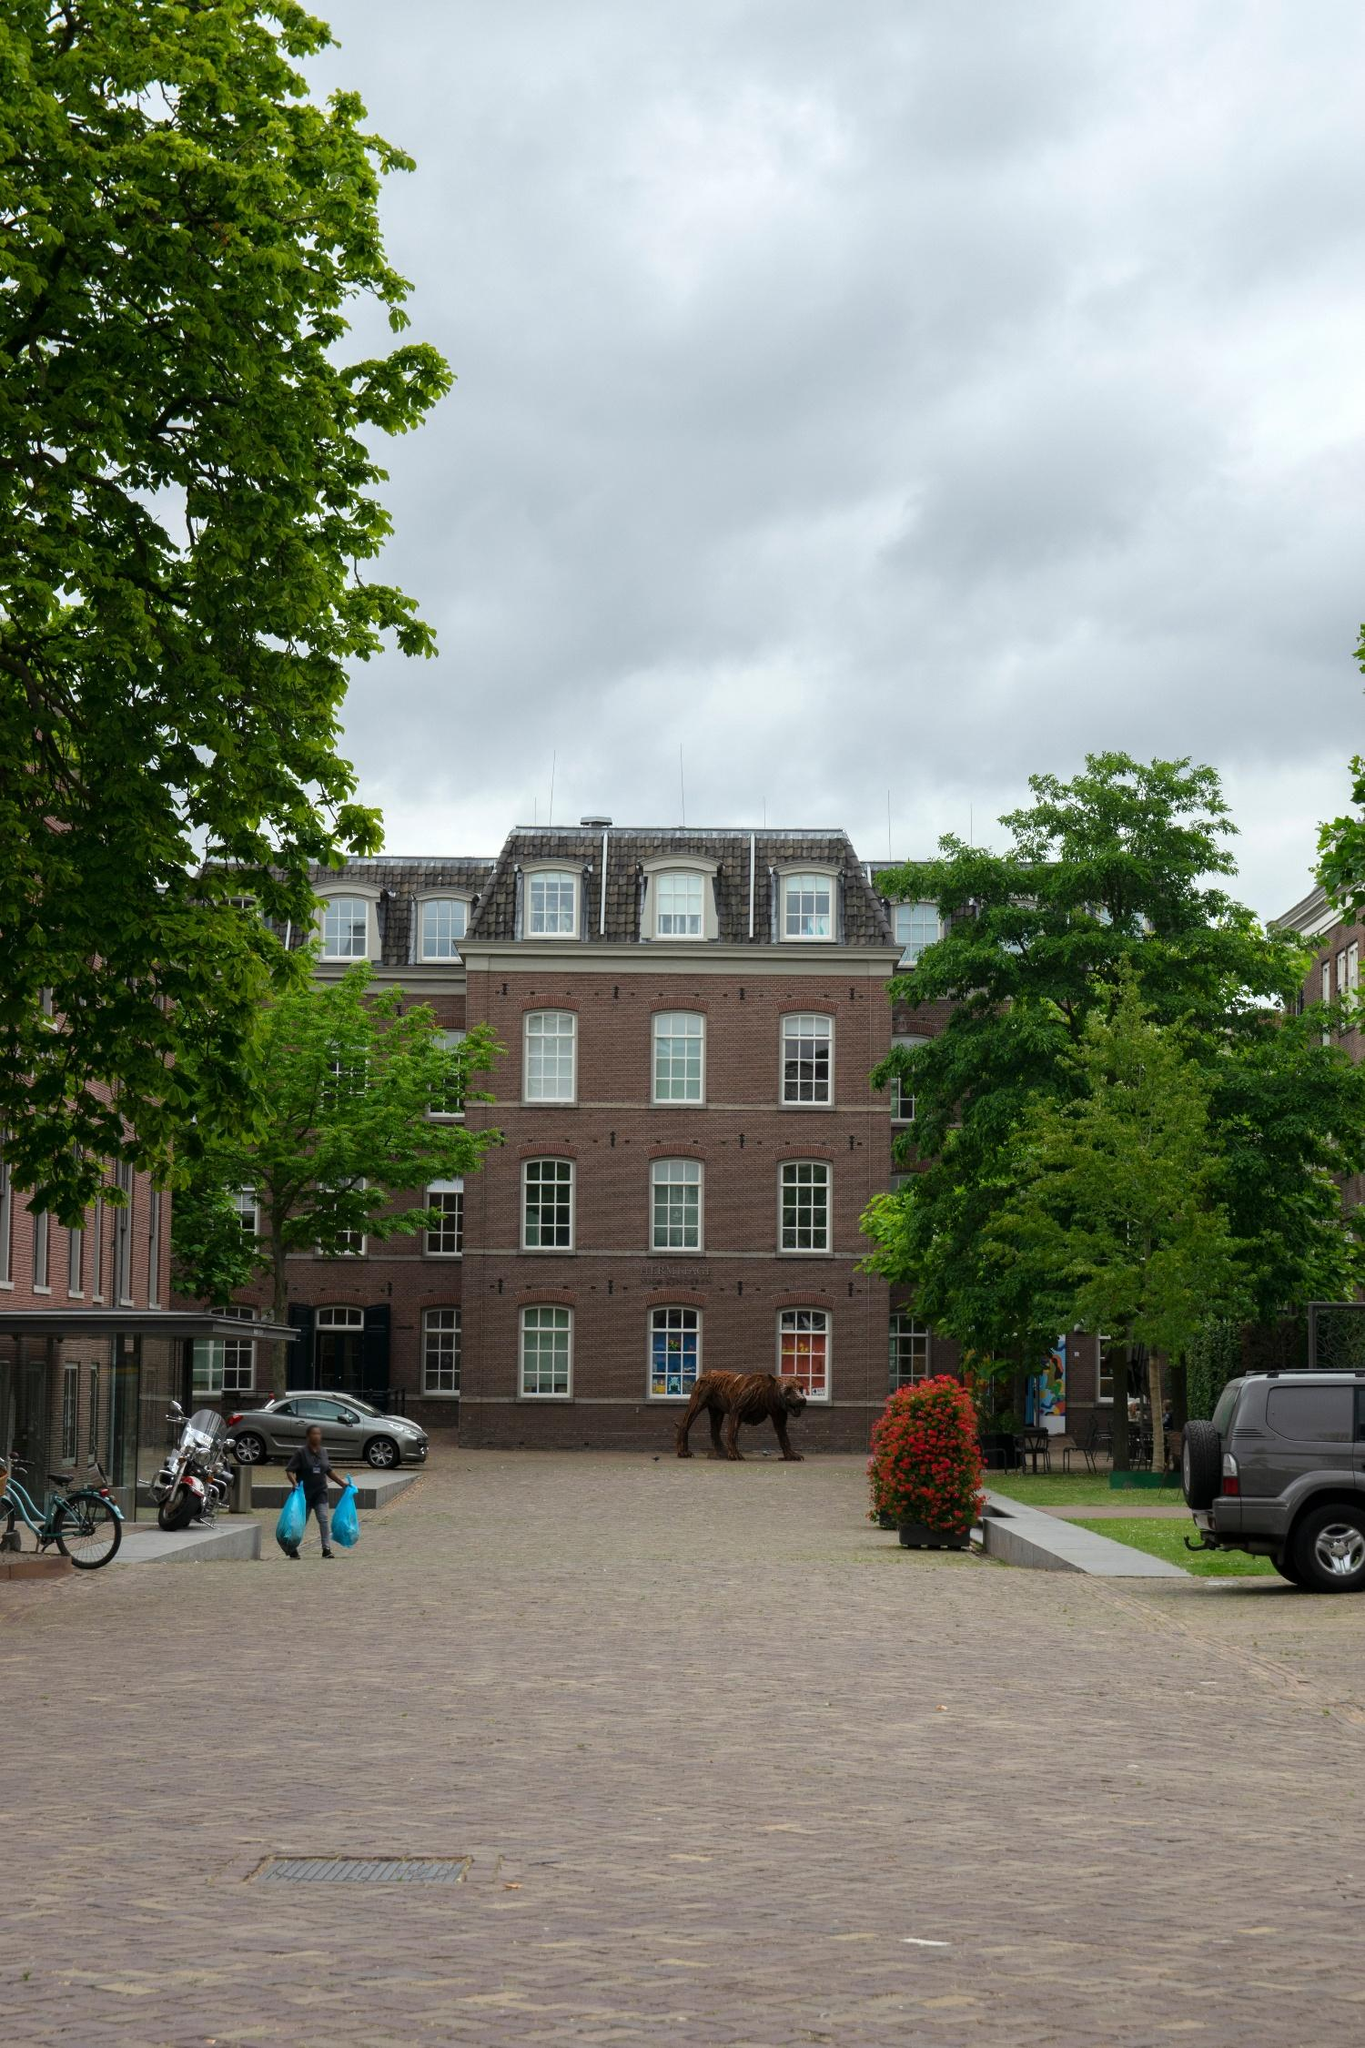Can you describe some unique features of this building? Certainly! The building in the image has a distinctive mansard roof, which is not very common in modern architecture. This roof style, which has steep sides and a flat top, is often associated with 17th-century French architecture. The use of red bricks coupled with white trim gives the building a timeless, classic look. The symmetry of the windows and the inclusion of black shutters provide a balanced, pleasing aesthetic. Additionally, the presence of a bear sculpture adds a unique artistic element that makes the building stand out even more. 